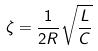Convert formula to latex. <formula><loc_0><loc_0><loc_500><loc_500>\zeta = \frac { 1 } { 2 R } \sqrt { \frac { L } { C } }</formula> 